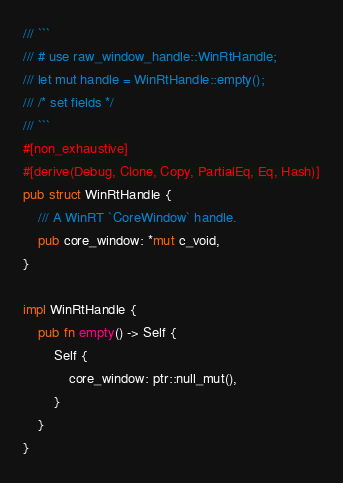<code> <loc_0><loc_0><loc_500><loc_500><_Rust_>/// ```
/// # use raw_window_handle::WinRtHandle;
/// let mut handle = WinRtHandle::empty();
/// /* set fields */
/// ```
#[non_exhaustive]
#[derive(Debug, Clone, Copy, PartialEq, Eq, Hash)]
pub struct WinRtHandle {
    /// A WinRT `CoreWindow` handle.
    pub core_window: *mut c_void,
}

impl WinRtHandle {
    pub fn empty() -> Self {
        Self {
            core_window: ptr::null_mut(),
        }
    }
}
</code> 